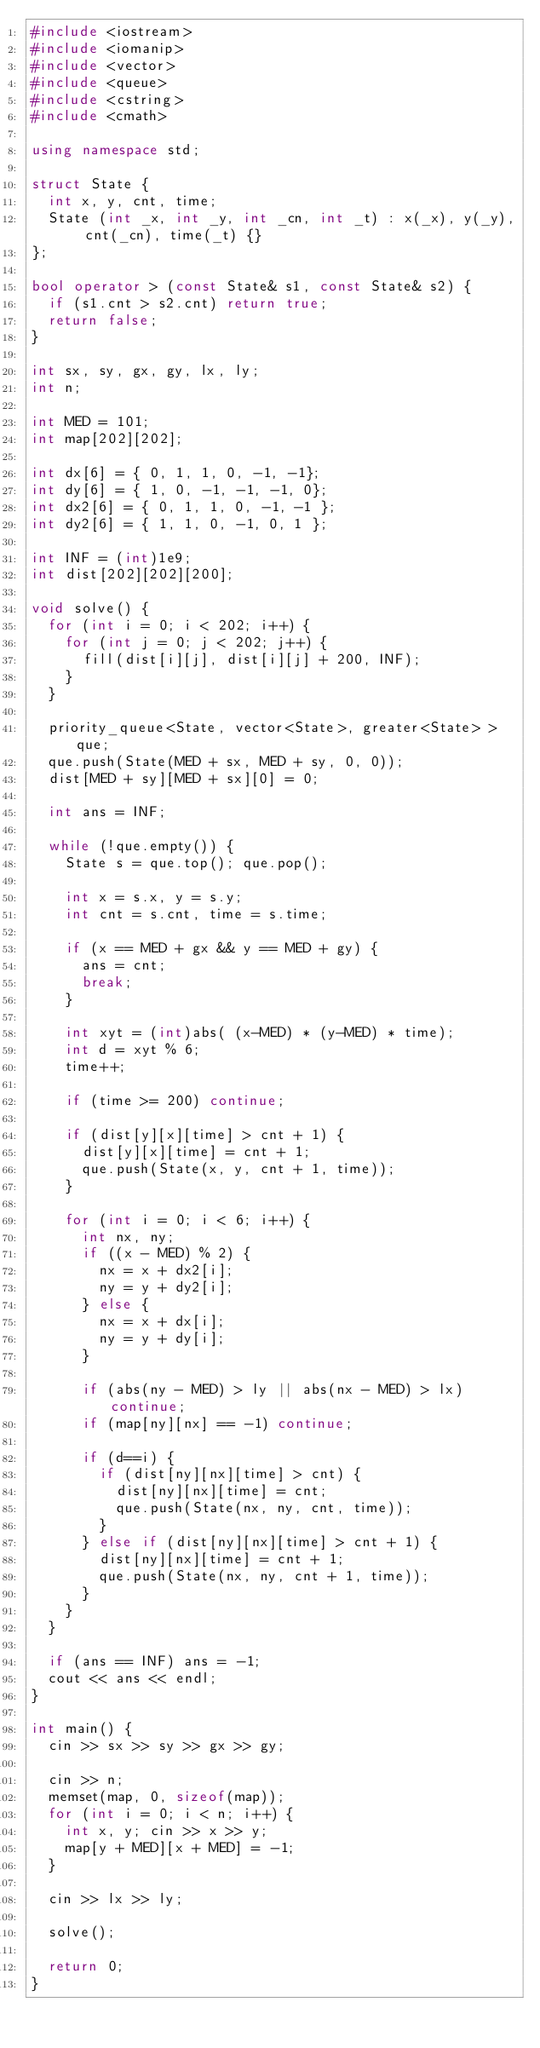<code> <loc_0><loc_0><loc_500><loc_500><_C++_>#include <iostream>
#include <iomanip>
#include <vector>
#include <queue>
#include <cstring>
#include <cmath>

using namespace std;

struct State {
	int x, y, cnt, time;
	State (int _x, int _y, int _cn, int _t) : x(_x), y(_y), cnt(_cn), time(_t) {}
}; 

bool operator > (const State& s1, const State& s2) {
	if (s1.cnt > s2.cnt) return true;
	return false;
}

int sx, sy, gx, gy, lx, ly;
int n;

int MED = 101;
int map[202][202];

int dx[6] = { 0, 1, 1, 0, -1, -1};
int dy[6] = { 1, 0, -1, -1, -1, 0};
int dx2[6] = { 0, 1, 1, 0, -1, -1 };
int dy2[6] = { 1, 1, 0, -1, 0, 1 };

int INF = (int)1e9;
int dist[202][202][200];

void solve() {
	for (int i = 0; i < 202; i++) {
		for (int j = 0; j < 202; j++) {
			fill(dist[i][j], dist[i][j] + 200, INF);
		}
	}
	
	priority_queue<State, vector<State>, greater<State> > que;
	que.push(State(MED + sx, MED + sy, 0, 0));
	dist[MED + sy][MED + sx][0] = 0;
	
	int ans = INF;
	
	while (!que.empty()) {
		State s = que.top(); que.pop();
		
		int x = s.x, y = s.y;
		int cnt = s.cnt, time = s.time;
		
		if (x == MED + gx && y == MED + gy) {
			ans = cnt;
			break;
		}
		
		int xyt = (int)abs( (x-MED) * (y-MED) * time);
		int d = xyt % 6;
		time++;
		
		if (time >= 200) continue;
		
		if (dist[y][x][time] > cnt + 1) {
			dist[y][x][time] = cnt + 1;
			que.push(State(x, y, cnt + 1, time));
		}
		
		for (int i = 0; i < 6; i++) {
			int nx, ny;
			if ((x - MED) % 2) {
				nx = x + dx2[i];
				ny = y + dy2[i];
			} else {
				nx = x + dx[i];
				ny = y + dy[i];
			}
			
			if (abs(ny - MED) > ly || abs(nx - MED) > lx) continue;
			if (map[ny][nx] == -1) continue;
			
			if (d==i) {
				if (dist[ny][nx][time] > cnt) {
					dist[ny][nx][time] = cnt;
					que.push(State(nx, ny, cnt, time));
				}
			} else if (dist[ny][nx][time] > cnt + 1) {
				dist[ny][nx][time] = cnt + 1;
				que.push(State(nx, ny, cnt + 1, time));
			}
		}
	}
	
	if (ans == INF) ans = -1;
	cout << ans << endl;
}

int main() {
	cin >> sx >> sy >> gx >> gy;
	
	cin >> n;
	memset(map, 0, sizeof(map));
	for (int i = 0; i < n; i++) {
		int x, y; cin >> x >> y;
		map[y + MED][x + MED] = -1;
	}
	
	cin >> lx >> ly;
	
	solve();
	
	return 0;
}</code> 